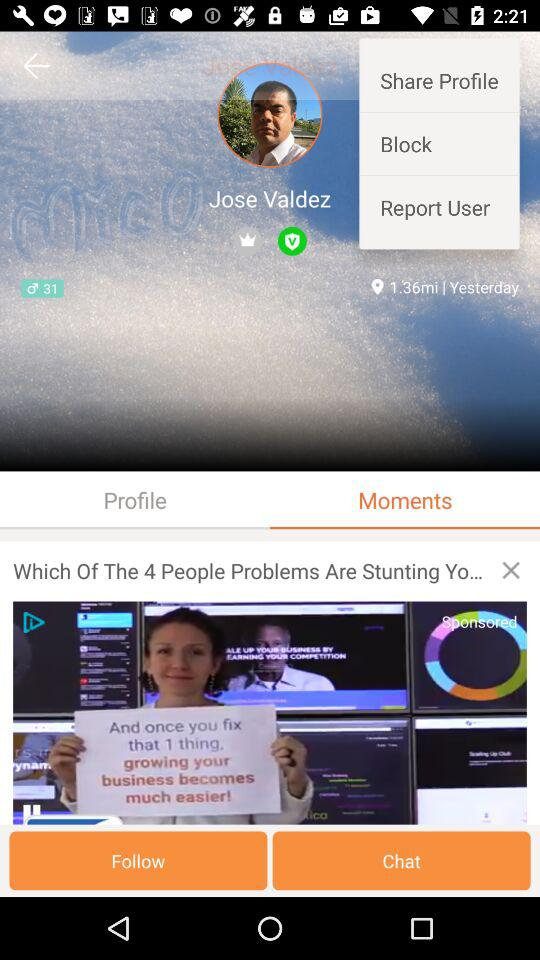What is the name of the user? The name of the user is Jose Valdez. 